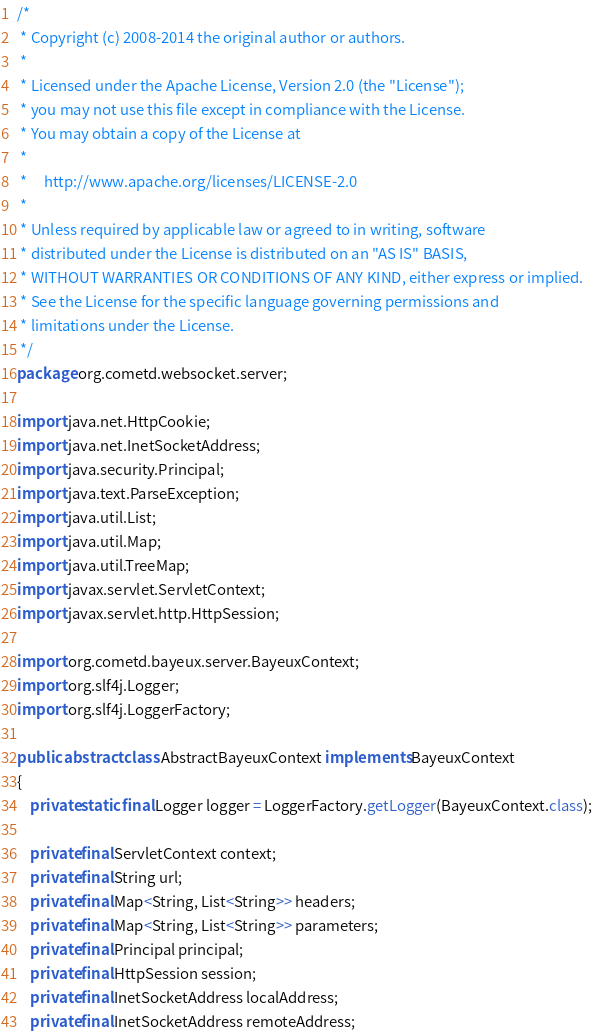Convert code to text. <code><loc_0><loc_0><loc_500><loc_500><_Java_>/*
 * Copyright (c) 2008-2014 the original author or authors.
 *
 * Licensed under the Apache License, Version 2.0 (the "License");
 * you may not use this file except in compliance with the License.
 * You may obtain a copy of the License at
 *
 *     http://www.apache.org/licenses/LICENSE-2.0
 *
 * Unless required by applicable law or agreed to in writing, software
 * distributed under the License is distributed on an "AS IS" BASIS,
 * WITHOUT WARRANTIES OR CONDITIONS OF ANY KIND, either express or implied.
 * See the License for the specific language governing permissions and
 * limitations under the License.
 */
package org.cometd.websocket.server;

import java.net.HttpCookie;
import java.net.InetSocketAddress;
import java.security.Principal;
import java.text.ParseException;
import java.util.List;
import java.util.Map;
import java.util.TreeMap;
import javax.servlet.ServletContext;
import javax.servlet.http.HttpSession;

import org.cometd.bayeux.server.BayeuxContext;
import org.slf4j.Logger;
import org.slf4j.LoggerFactory;

public abstract class AbstractBayeuxContext implements BayeuxContext
{
    private static final Logger logger = LoggerFactory.getLogger(BayeuxContext.class);

    private final ServletContext context;
    private final String url;
    private final Map<String, List<String>> headers;
    private final Map<String, List<String>> parameters;
    private final Principal principal;
    private final HttpSession session;
    private final InetSocketAddress localAddress;
    private final InetSocketAddress remoteAddress;
</code> 